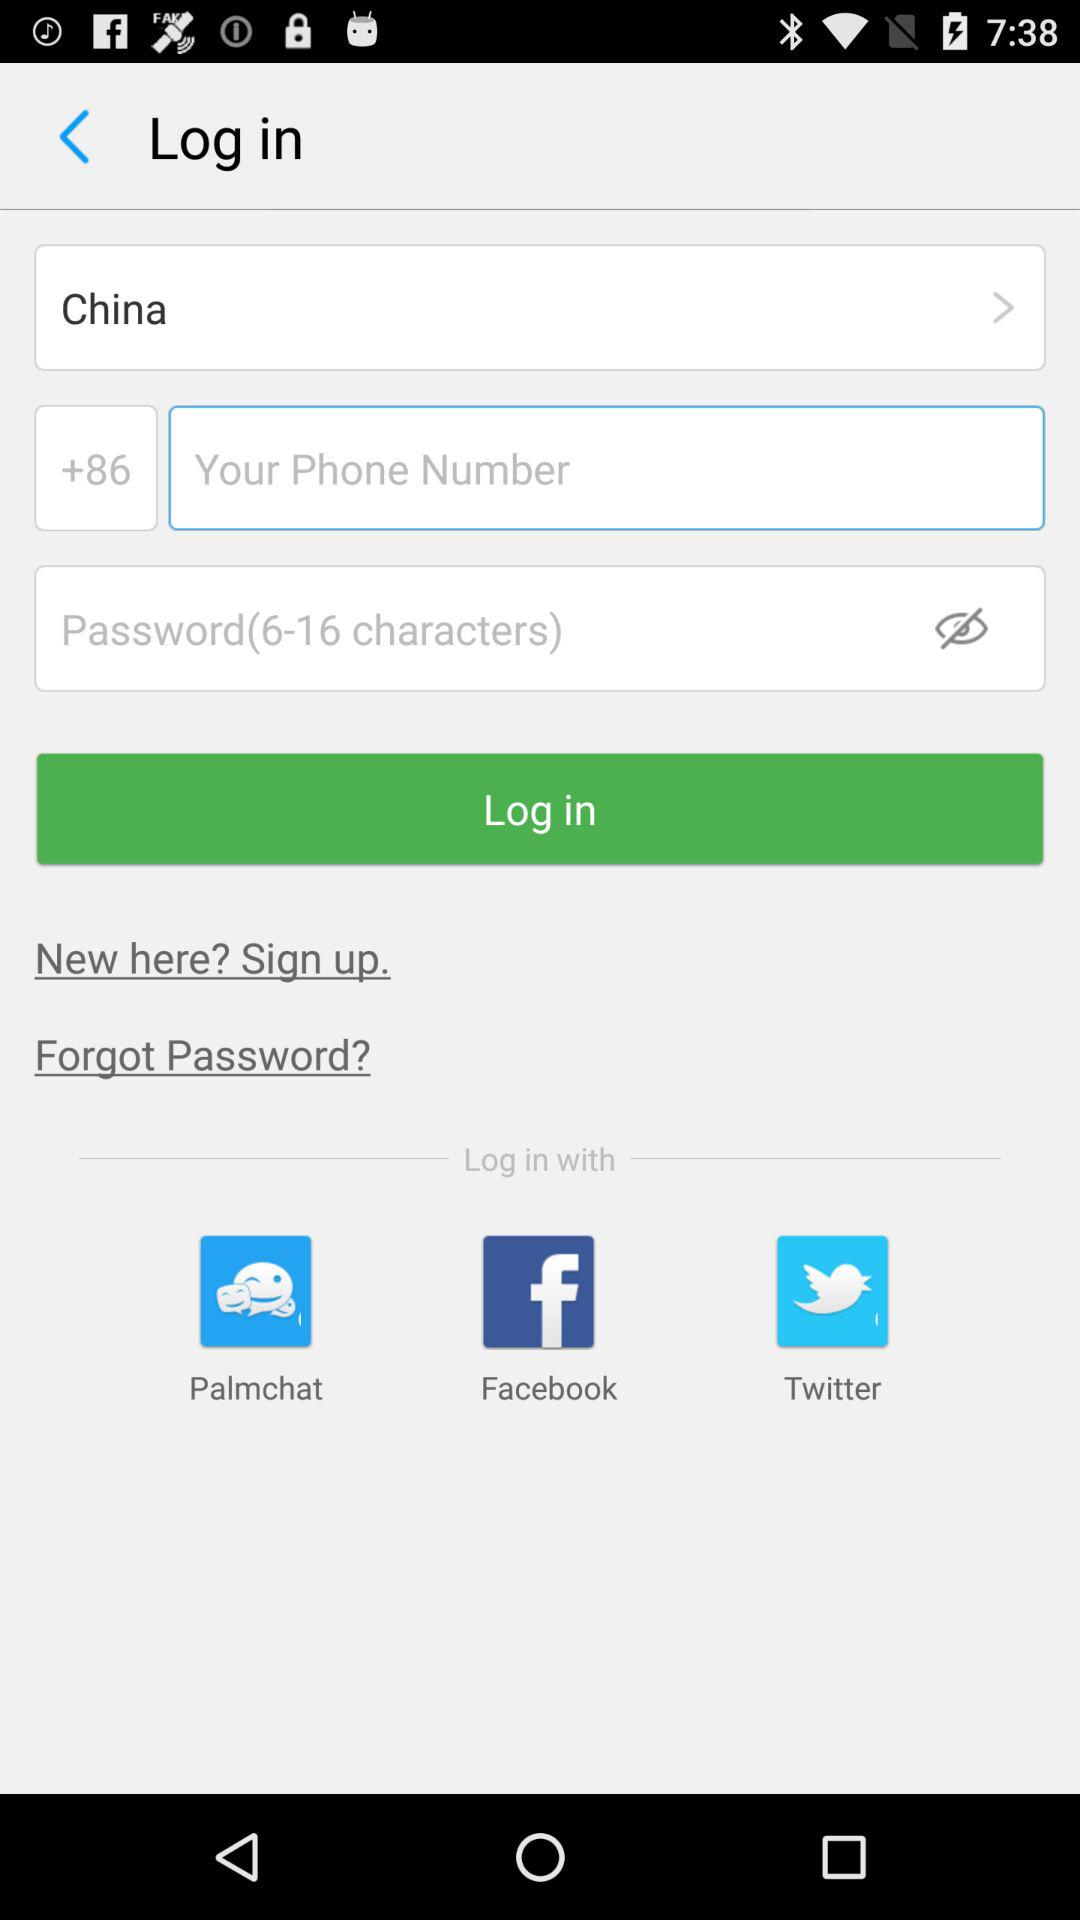Through what application can be log in? You can login with Palmchat, Facebook, and Twitter. 